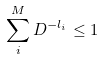Convert formula to latex. <formula><loc_0><loc_0><loc_500><loc_500>\sum _ { i } ^ { M } D ^ { - l _ { i } } \leq 1</formula> 